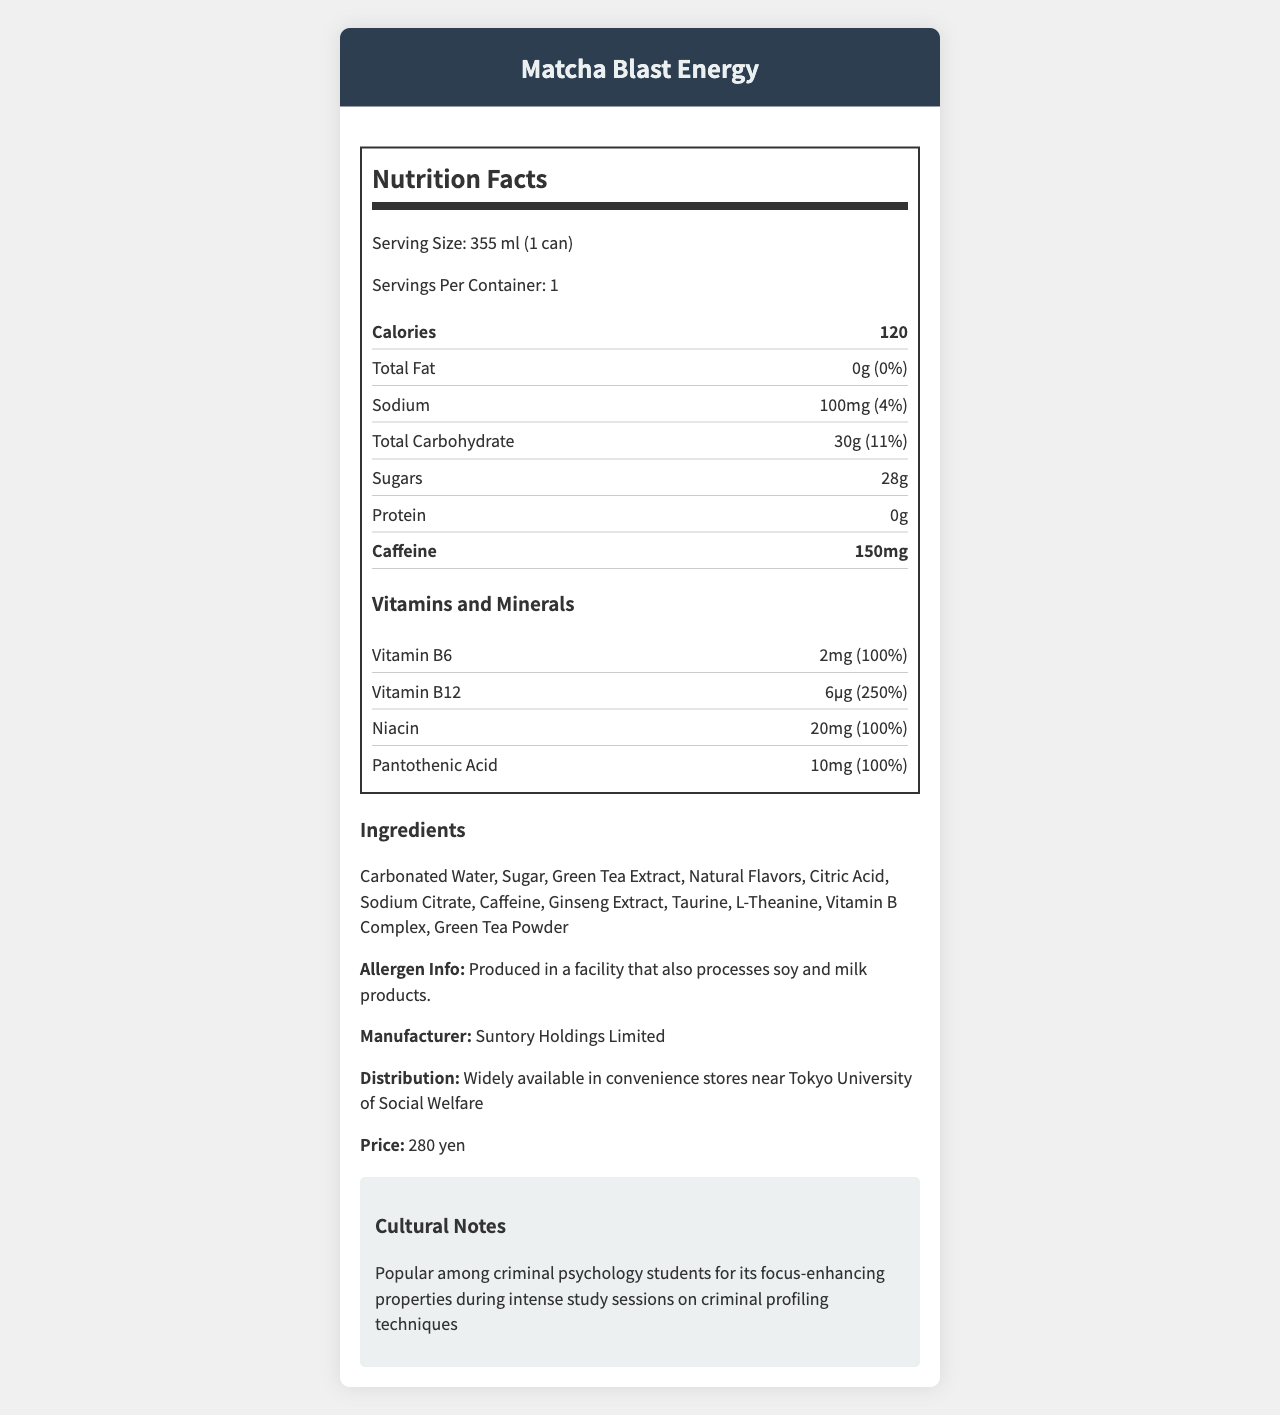what is the serving size of the "Matcha Blast Energy"? The document states that the serving size is "355 ml (1 can)".
Answer: 355 ml (1 can) How many calories are in one serving of "Matcha Blast Energy"? The document lists the calorie content as 120 per serving.
Answer: 120 What percentage of the daily value of sodium does one can of "Matcha Blast Energy" contain? The document specifies that there are 100mg of sodium, which corresponds to 4% of the daily value.
Answer: 4% How many grams of total sugars are in "Matcha Blast Energy"? The document shows that the total sugar content is 28g.
Answer: 28g What amount of caffeine is in "Matcha Blast Energy"? The document lists the caffeine content at 150mg per serving.
Answer: 150mg Which vitamins in "Matcha Blast Energy" provide 100% of the daily value? A. Vitamin B6 B. Vitamin B12 C. Niacin D. Pantothenic Acid E. A, C, and D The document states that Vitamin B6, Niacin, and Pantothenic Acid (options A, C, and D) each provide 100% of the daily value.
Answer: E How much Vitamin B12 is in "Matcha Blast Energy"? A. 2 mg B. 6 μg C. 10 mg D. 20 mg The document clearly shows that Vitamin B12 content is 6 μg.
Answer: B Is the document's name "Nutrition Facts: Matcha Blast Energy"? The title of the document is "Nutrition Facts: Matcha Blast Energy".
Answer: Yes Summarize the main idea of the document. The document provides detailed nutritional information, including ingredients and manufacturer details, for the Matcha Blast Energy drink, highlighting its appeal for university students studying late at night and its popularity among criminal psychology students for its focus-enhancing properties.
Answer: Matcha Blast Energy is a green tea-flavored energy drink targeted towards university students, especially those studying late nights. It contains 120 calories, 0g fat, 100mg sodium, 30g carbohydrates (including 28g sugar), 0g protein, and 150mg caffeine per serving. It boasts a high content of vitamins like Vitamin B6, B12, Niacin, and Pantothenic Acid. The drink also has ingredients like carbonated water, sugar, green tea extract, and more, and is produced by Suntory Holdings Limited. What is the target price of one can of "Matcha Blast Energy"? The document specifies that the price of one can is 280 yen.
Answer: 280 yen Which manufacturer produces "Matcha Blast Energy"? The document mentions that the manufacturer is Suntory Holdings Limited.
Answer: Suntory Holdings Limited What are some key ingredients in "Matcha Blast Energy"? The document lists these ingredients among others in the drink.
Answer: Carbonated Water, Sugar, Green Tea Extract, Natural Flavors What are the total carbohydrates in one serving of "Matcha Blast Energy"? The document shows that the total carbohydrate content is 30g.
Answer: 30g Where is "Matcha Blast Energy" widely available? The document mentions that it is widely available in convenience stores near Tokyo University of Social Welfare.
Answer: Convenience stores near Tokyo University of Social Welfare Does the document mention if "Matcha Blast Energy" is suitable for people with milk allergies? The allergen information notes that it is produced in a facility that also processes soy and milk products, but does not explicitly state if it's suitable or not for those with milk allergies.
Answer: No, it states that it is produced in a facility that also processes soy and milk products. Does "Matcha Blast Energy" contain any fat? The document lists the total fat content as 0g, which is 0% of the daily value.
Answer: No 